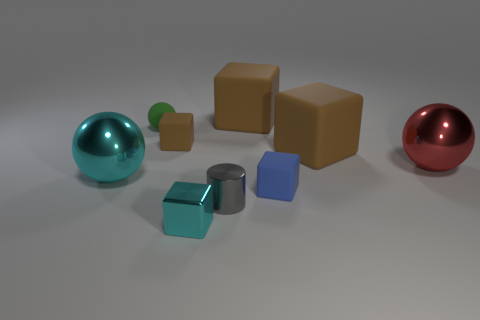Can you compare the textures of the objects in the image? Certainly. The cyan metal block appears to have a smooth and reflective texture, hinting at a hard and possibly cold surface. In contrast, the blue rubber object seems to have a matte and softer texture, which might feel pliable or squishy to the touch. Observing textures gives us clues about the materials and potential uses of these objects. 